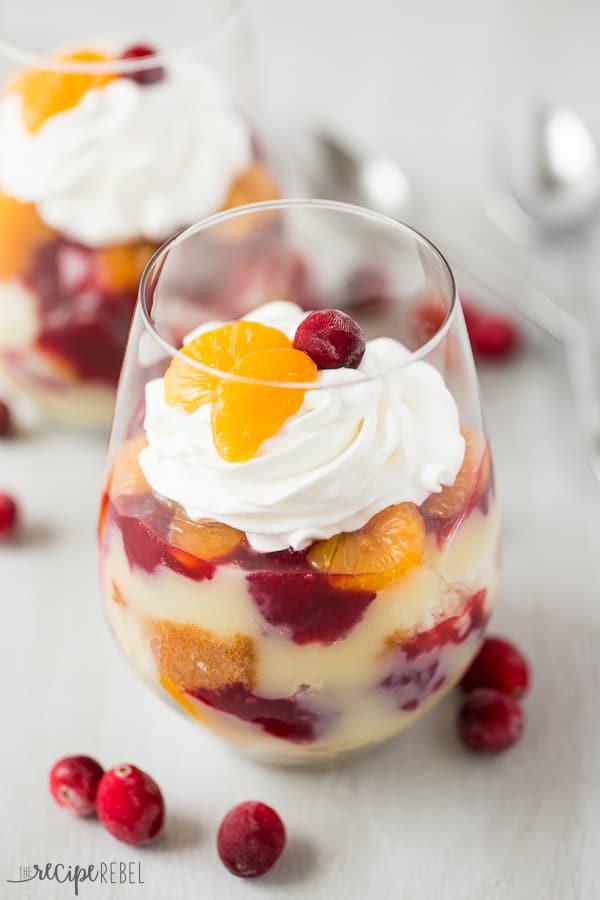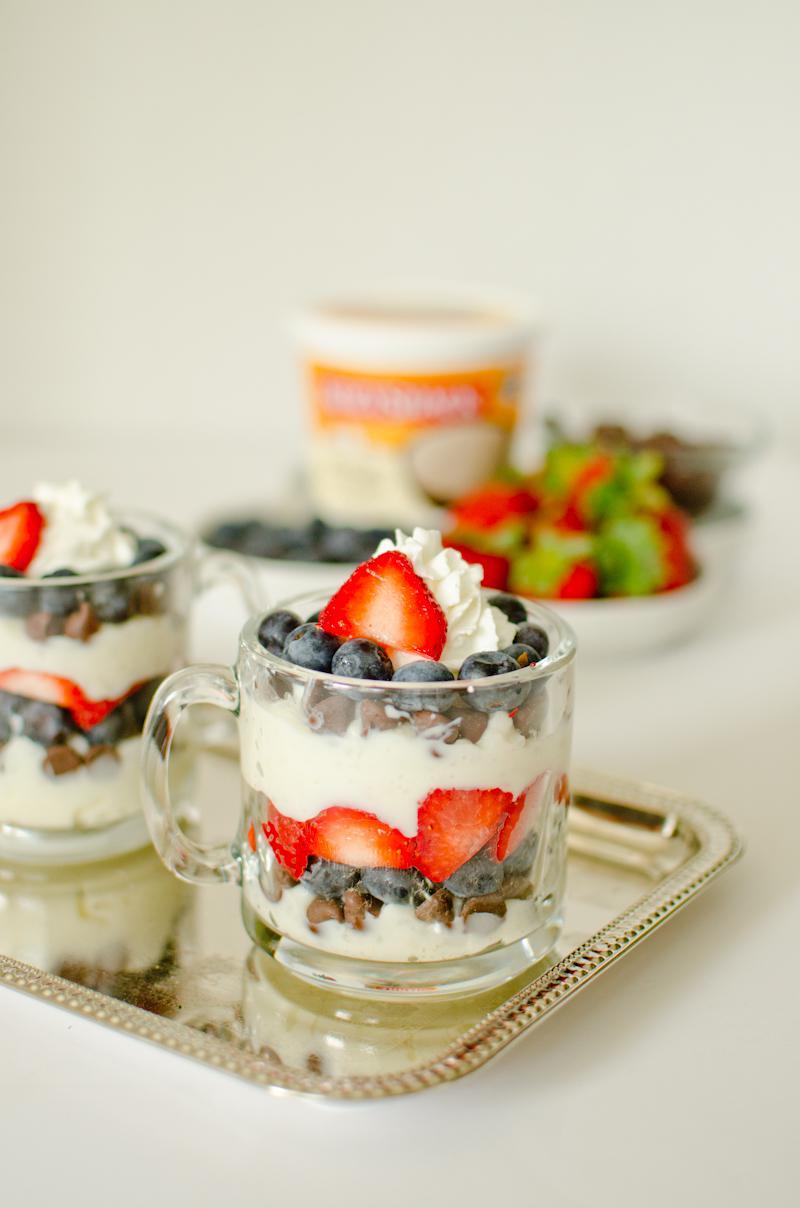The first image is the image on the left, the second image is the image on the right. Assess this claim about the two images: "One image shows a single large trifle dessert in a footed serving bowl.". Correct or not? Answer yes or no. No. 